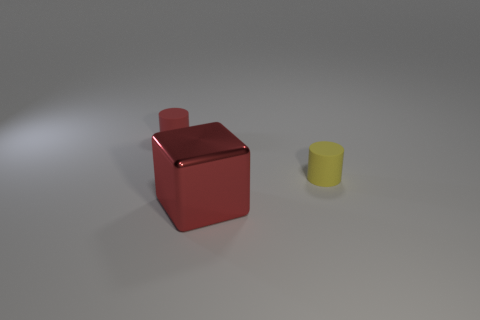There is a thing that is the same color as the big block; what size is it?
Provide a short and direct response. Small. There is a tiny matte cylinder in front of the red cylinder; does it have the same color as the metallic thing?
Give a very brief answer. No. How many shiny cubes are the same size as the red matte thing?
Offer a very short reply. 0. Is there another large cube that has the same color as the large block?
Ensure brevity in your answer.  No. Does the big object have the same material as the yellow cylinder?
Your answer should be very brief. No. What number of small yellow objects have the same shape as the small red matte thing?
Ensure brevity in your answer.  1. What shape is the other object that is made of the same material as the small yellow thing?
Offer a very short reply. Cylinder. There is a tiny cylinder that is to the left of the small rubber object in front of the tiny red rubber object; what color is it?
Ensure brevity in your answer.  Red. There is a small cylinder behind the cylinder right of the red metallic block; what is it made of?
Give a very brief answer. Rubber. What is the material of the other small thing that is the same shape as the tiny yellow matte object?
Provide a succinct answer. Rubber. 